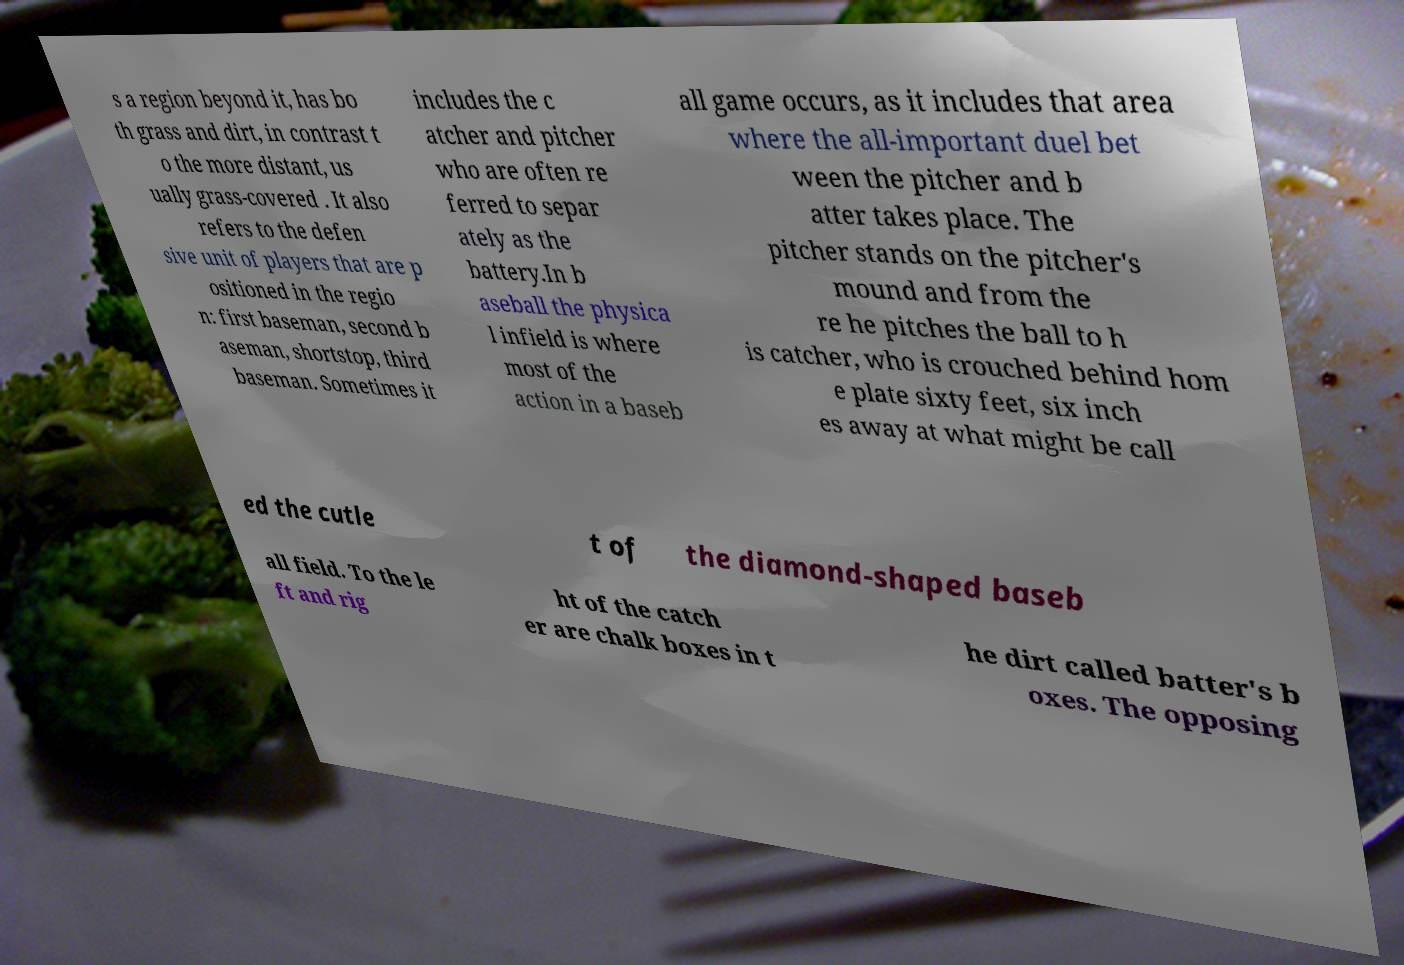Please read and relay the text visible in this image. What does it say? s a region beyond it, has bo th grass and dirt, in contrast t o the more distant, us ually grass-covered . It also refers to the defen sive unit of players that are p ositioned in the regio n: first baseman, second b aseman, shortstop, third baseman. Sometimes it includes the c atcher and pitcher who are often re ferred to separ ately as the battery.In b aseball the physica l infield is where most of the action in a baseb all game occurs, as it includes that area where the all-important duel bet ween the pitcher and b atter takes place. The pitcher stands on the pitcher's mound and from the re he pitches the ball to h is catcher, who is crouched behind hom e plate sixty feet, six inch es away at what might be call ed the cutle t of the diamond-shaped baseb all field. To the le ft and rig ht of the catch er are chalk boxes in t he dirt called batter's b oxes. The opposing 